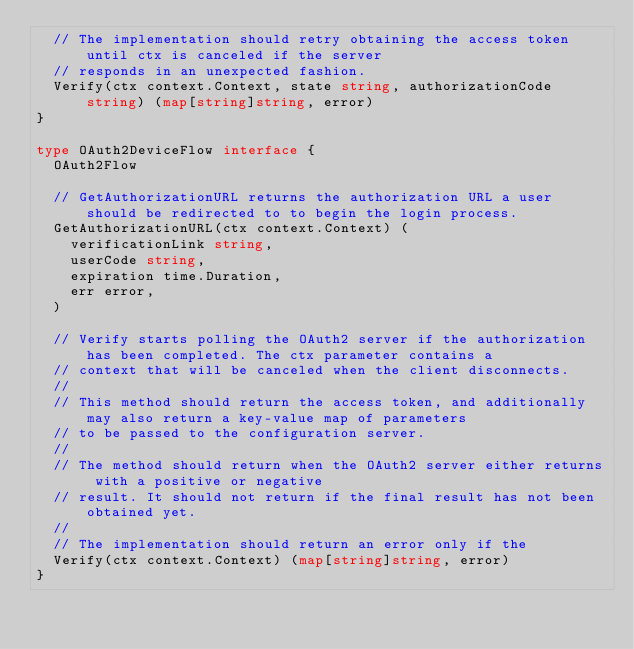Convert code to text. <code><loc_0><loc_0><loc_500><loc_500><_Go_>	// The implementation should retry obtaining the access token until ctx is canceled if the server
	// responds in an unexpected fashion.
	Verify(ctx context.Context, state string, authorizationCode string) (map[string]string, error)
}

type OAuth2DeviceFlow interface {
	OAuth2Flow

	// GetAuthorizationURL returns the authorization URL a user should be redirected to to begin the login process.
	GetAuthorizationURL(ctx context.Context) (
		verificationLink string,
		userCode string,
		expiration time.Duration,
		err error,
	)

	// Verify starts polling the OAuth2 server if the authorization has been completed. The ctx parameter contains a
	// context that will be canceled when the client disconnects.
	//
	// This method should return the access token, and additionally may also return a key-value map of parameters
	// to be passed to the configuration server.
	//
	// The method should return when the OAuth2 server either returns with a positive or negative
	// result. It should not return if the final result has not been obtained yet.
	//
	// The implementation should return an error only if the
	Verify(ctx context.Context) (map[string]string, error)
}</code> 